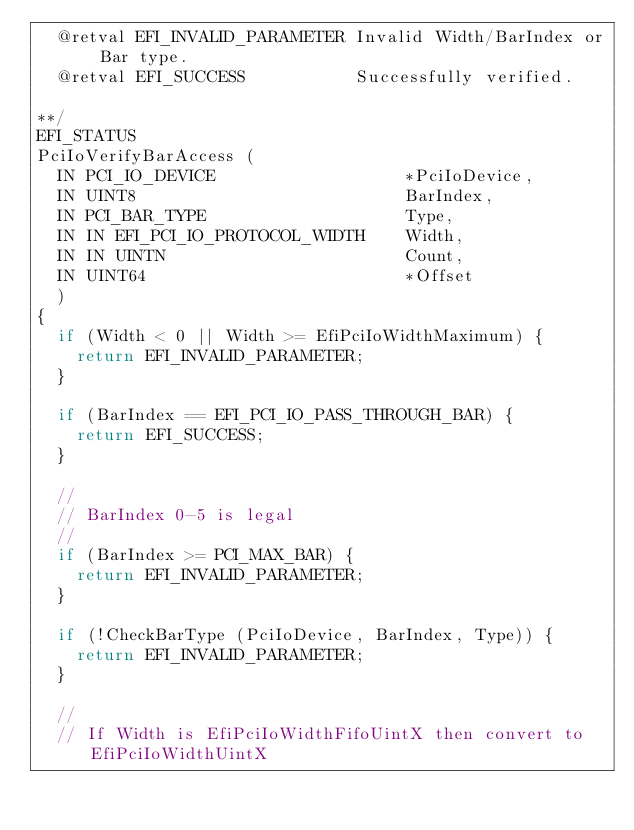<code> <loc_0><loc_0><loc_500><loc_500><_C_>  @retval EFI_INVALID_PARAMETER Invalid Width/BarIndex or Bar type.
  @retval EFI_SUCCESS           Successfully verified.

**/
EFI_STATUS
PciIoVerifyBarAccess (
  IN PCI_IO_DEVICE                   *PciIoDevice,
  IN UINT8                           BarIndex,
  IN PCI_BAR_TYPE                    Type,
  IN IN EFI_PCI_IO_PROTOCOL_WIDTH    Width,
  IN IN UINTN                        Count,
  IN UINT64                          *Offset
  )
{
  if (Width < 0 || Width >= EfiPciIoWidthMaximum) {
    return EFI_INVALID_PARAMETER;
  }

  if (BarIndex == EFI_PCI_IO_PASS_THROUGH_BAR) {
    return EFI_SUCCESS;
  }

  //
  // BarIndex 0-5 is legal
  //
  if (BarIndex >= PCI_MAX_BAR) {
    return EFI_INVALID_PARAMETER;
  }

  if (!CheckBarType (PciIoDevice, BarIndex, Type)) {
    return EFI_INVALID_PARAMETER;
  }

  //
  // If Width is EfiPciIoWidthFifoUintX then convert to EfiPciIoWidthUintX</code> 